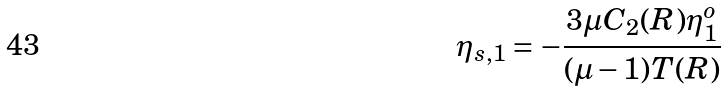Convert formula to latex. <formula><loc_0><loc_0><loc_500><loc_500>\eta _ { s , 1 } = - \frac { 3 \mu C _ { 2 } ( R ) \eta ^ { o } _ { 1 } } { ( \mu - 1 ) T ( R ) }</formula> 